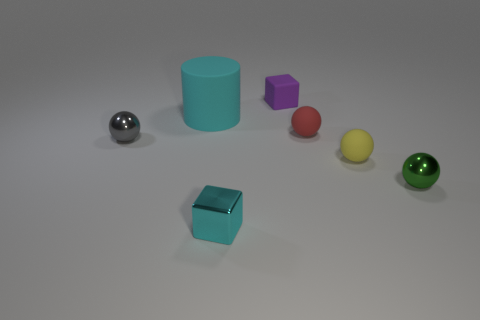How many matte objects are there?
Give a very brief answer. 4. How many objects are the same size as the rubber block?
Your answer should be very brief. 5. What material is the yellow thing?
Keep it short and to the point. Rubber. There is a large thing; is it the same color as the tiny cube that is in front of the red object?
Offer a very short reply. Yes. Are there any other things that are the same size as the cyan cylinder?
Offer a very short reply. No. There is a object that is both behind the red thing and on the left side of the purple thing; what size is it?
Give a very brief answer. Large. What is the shape of the purple object that is the same material as the tiny yellow thing?
Your answer should be compact. Cube. Is the big thing made of the same material as the cube behind the small gray thing?
Provide a short and direct response. Yes. There is a tiny cube that is in front of the yellow sphere; are there any small cubes on the right side of it?
Provide a succinct answer. Yes. There is a gray object that is the same shape as the small yellow matte object; what is it made of?
Your response must be concise. Metal. 